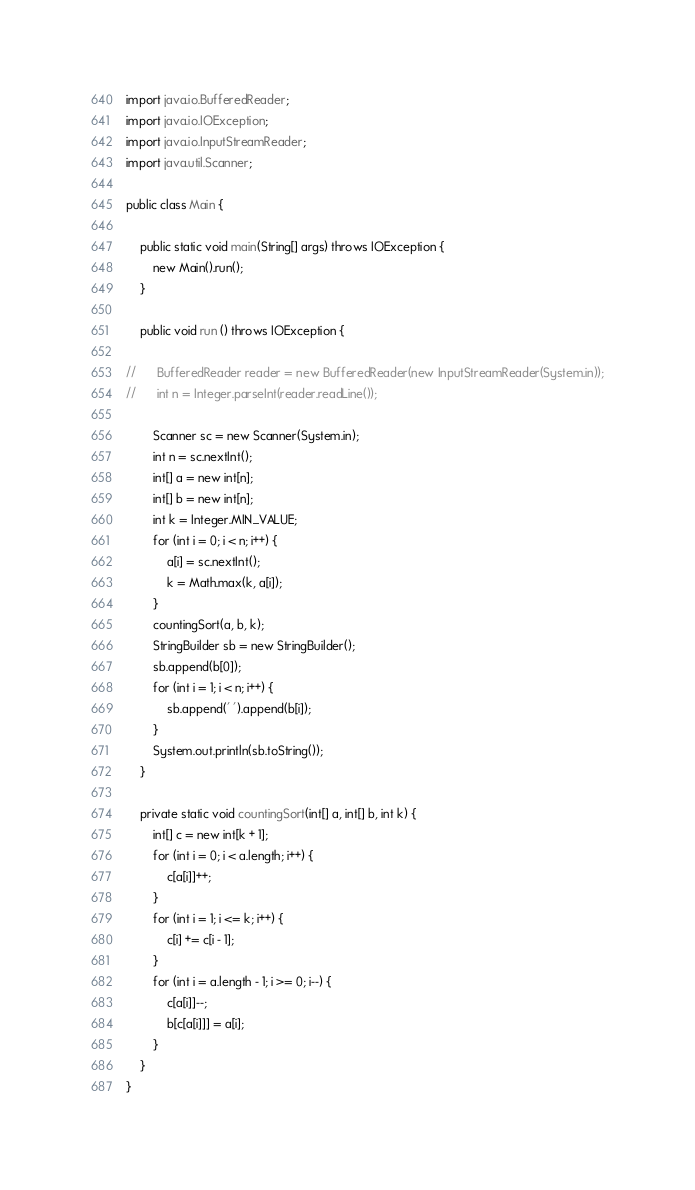<code> <loc_0><loc_0><loc_500><loc_500><_Java_>import java.io.BufferedReader;
import java.io.IOException;
import java.io.InputStreamReader;
import java.util.Scanner;

public class Main {

	public static void main(String[] args) throws IOException {
		new Main().run();
	}
	
	public void run () throws IOException {
		
//		BufferedReader reader = new BufferedReader(new InputStreamReader(System.in));
//		int n = Integer.parseInt(reader.readLine());
		
		Scanner sc = new Scanner(System.in);
		int n = sc.nextInt();
		int[] a = new int[n];
		int[] b = new int[n];
		int k = Integer.MIN_VALUE;
		for (int i = 0; i < n; i++) {
			a[i] = sc.nextInt();
			k = Math.max(k, a[i]);
		}
		countingSort(a, b, k);
		StringBuilder sb = new StringBuilder();
		sb.append(b[0]);
		for (int i = 1; i < n; i++) {
			sb.append(' ').append(b[i]);
		}
		System.out.println(sb.toString());
	}

	private static void countingSort(int[] a, int[] b, int k) {
		int[] c = new int[k + 1];
		for (int i = 0; i < a.length; i++) {
			c[a[i]]++;
		}
		for (int i = 1; i <= k; i++) {
			c[i] += c[i - 1];
		}
		for (int i = a.length - 1; i >= 0; i--) {
			c[a[i]]--;
			b[c[a[i]]] = a[i];
		}		
	}
}
</code> 